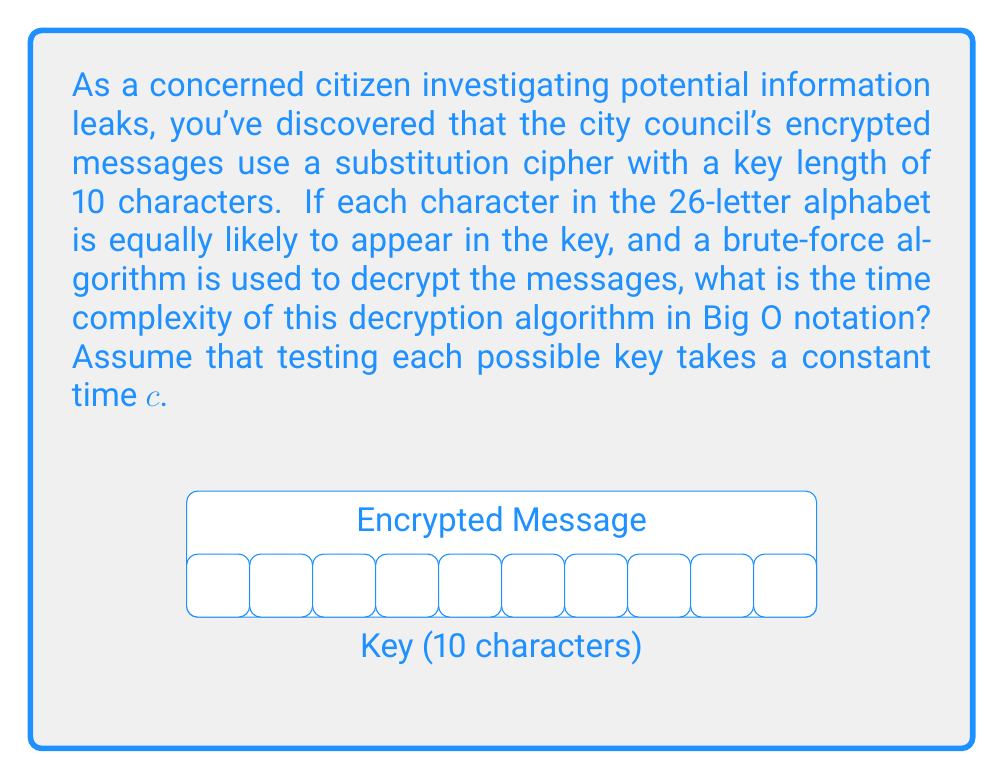Teach me how to tackle this problem. To solve this problem, let's break it down step-by-step:

1) First, we need to calculate the total number of possible keys:
   - There are 26 possible characters for each position in the key.
   - The key length is 10 characters.
   - So, the total number of possible keys is $26^{10}$.

2) The brute-force algorithm needs to try every possible key until it finds the correct one.
   - In the worst case, it will need to try all $26^{10}$ keys.
   - Each key test takes constant time $c$.

3) Therefore, the total time in the worst case is:
   $T(n) = c \cdot 26^{10}$

4) In Big O notation, we drop constant factors and focus on the growth rate.
   So, $O(26^{10})$ becomes $O(1)$, because 26 and 10 are constants.

5) However, if we consider the key length as a variable $n$ instead of a fixed 10,
   the time complexity would be $O(26^n)$ or simplified to $O(2^n)$, 
   as $26^n$ and $2^n$ have the same exponential growth rate.

Thus, the time complexity of this decryption algorithm is $O(1)$ for a fixed key length of 10,
or $O(2^n)$ if we consider the key length $n$ as a variable.
Answer: $O(1)$ for fixed key length; $O(2^n)$ for variable key length $n$ 